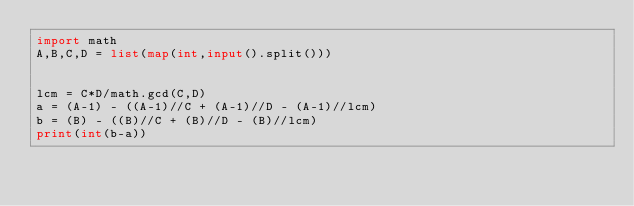Convert code to text. <code><loc_0><loc_0><loc_500><loc_500><_Python_>import math
A,B,C,D = list(map(int,input().split()))

 
lcm = C*D/math.gcd(C,D)
a = (A-1) - ((A-1)//C + (A-1)//D - (A-1)//lcm)
b = (B) - ((B)//C + (B)//D - (B)//lcm)
print(int(b-a))</code> 